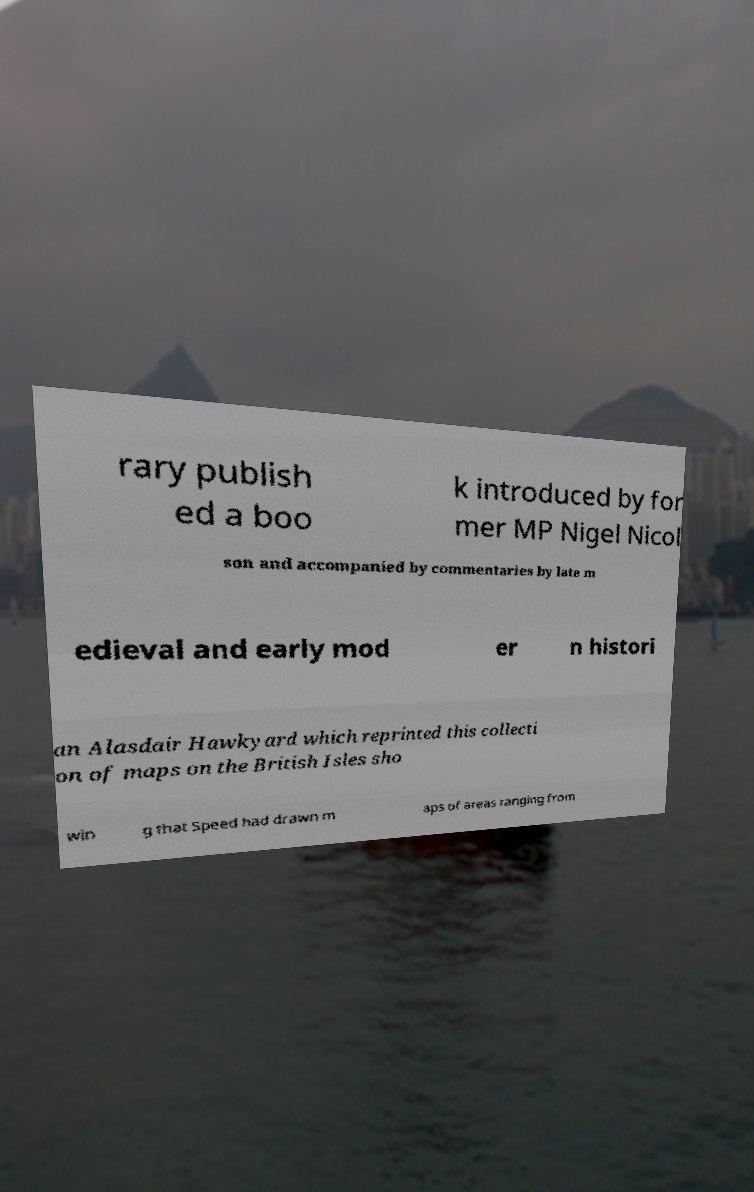What messages or text are displayed in this image? I need them in a readable, typed format. rary publish ed a boo k introduced by for mer MP Nigel Nicol son and accompanied by commentaries by late m edieval and early mod er n histori an Alasdair Hawkyard which reprinted this collecti on of maps on the British Isles sho win g that Speed had drawn m aps of areas ranging from 